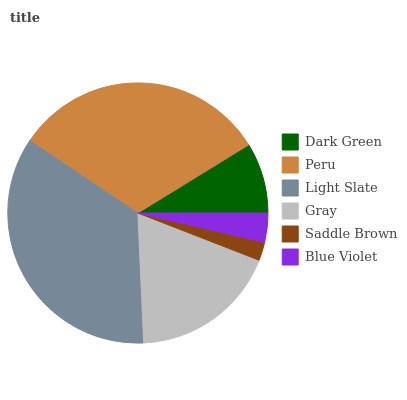Is Saddle Brown the minimum?
Answer yes or no. Yes. Is Light Slate the maximum?
Answer yes or no. Yes. Is Peru the minimum?
Answer yes or no. No. Is Peru the maximum?
Answer yes or no. No. Is Peru greater than Dark Green?
Answer yes or no. Yes. Is Dark Green less than Peru?
Answer yes or no. Yes. Is Dark Green greater than Peru?
Answer yes or no. No. Is Peru less than Dark Green?
Answer yes or no. No. Is Gray the high median?
Answer yes or no. Yes. Is Dark Green the low median?
Answer yes or no. Yes. Is Blue Violet the high median?
Answer yes or no. No. Is Light Slate the low median?
Answer yes or no. No. 